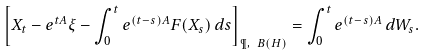Convert formula to latex. <formula><loc_0><loc_0><loc_500><loc_500>\left [ X _ { t } - e ^ { t A } \xi - \int _ { 0 } ^ { t } e ^ { ( t - s ) A } F ( X _ { s } ) \, d s \right ] _ { \P , \ B ( H ) } = \int _ { 0 } ^ { t } e ^ { ( t - s ) A } \, d W _ { s } .</formula> 